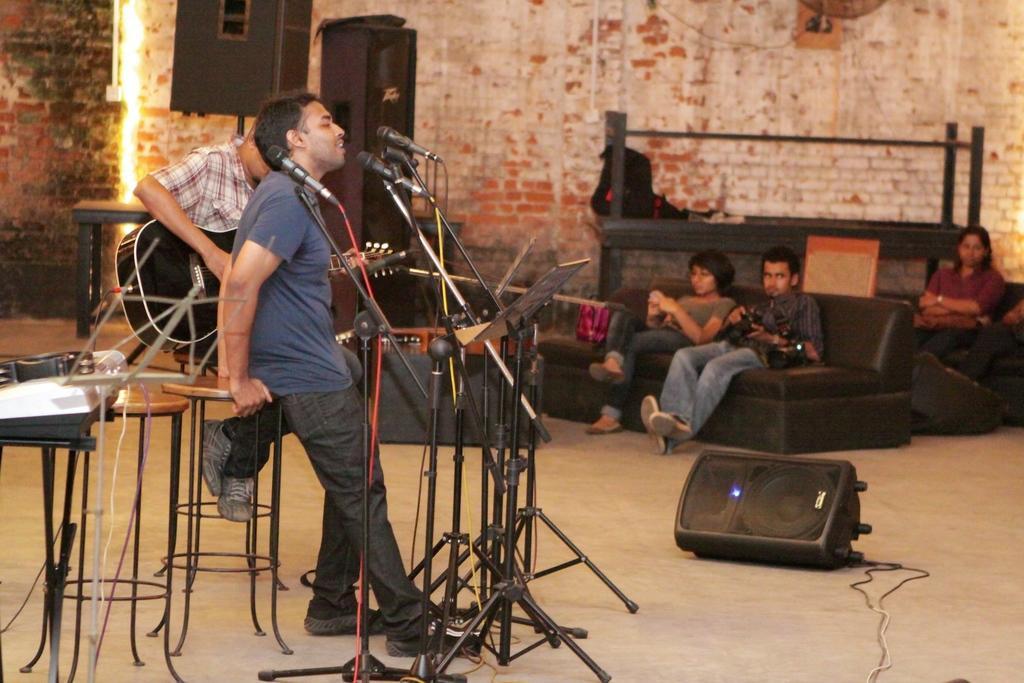How would you summarize this image in a sentence or two? In this image I can see few stools, a stand, a speaker and number of mics in the front. I can also see few people where one is standing and rest all are sitting. In the background I can see few sofas, few speakers and few other things. 